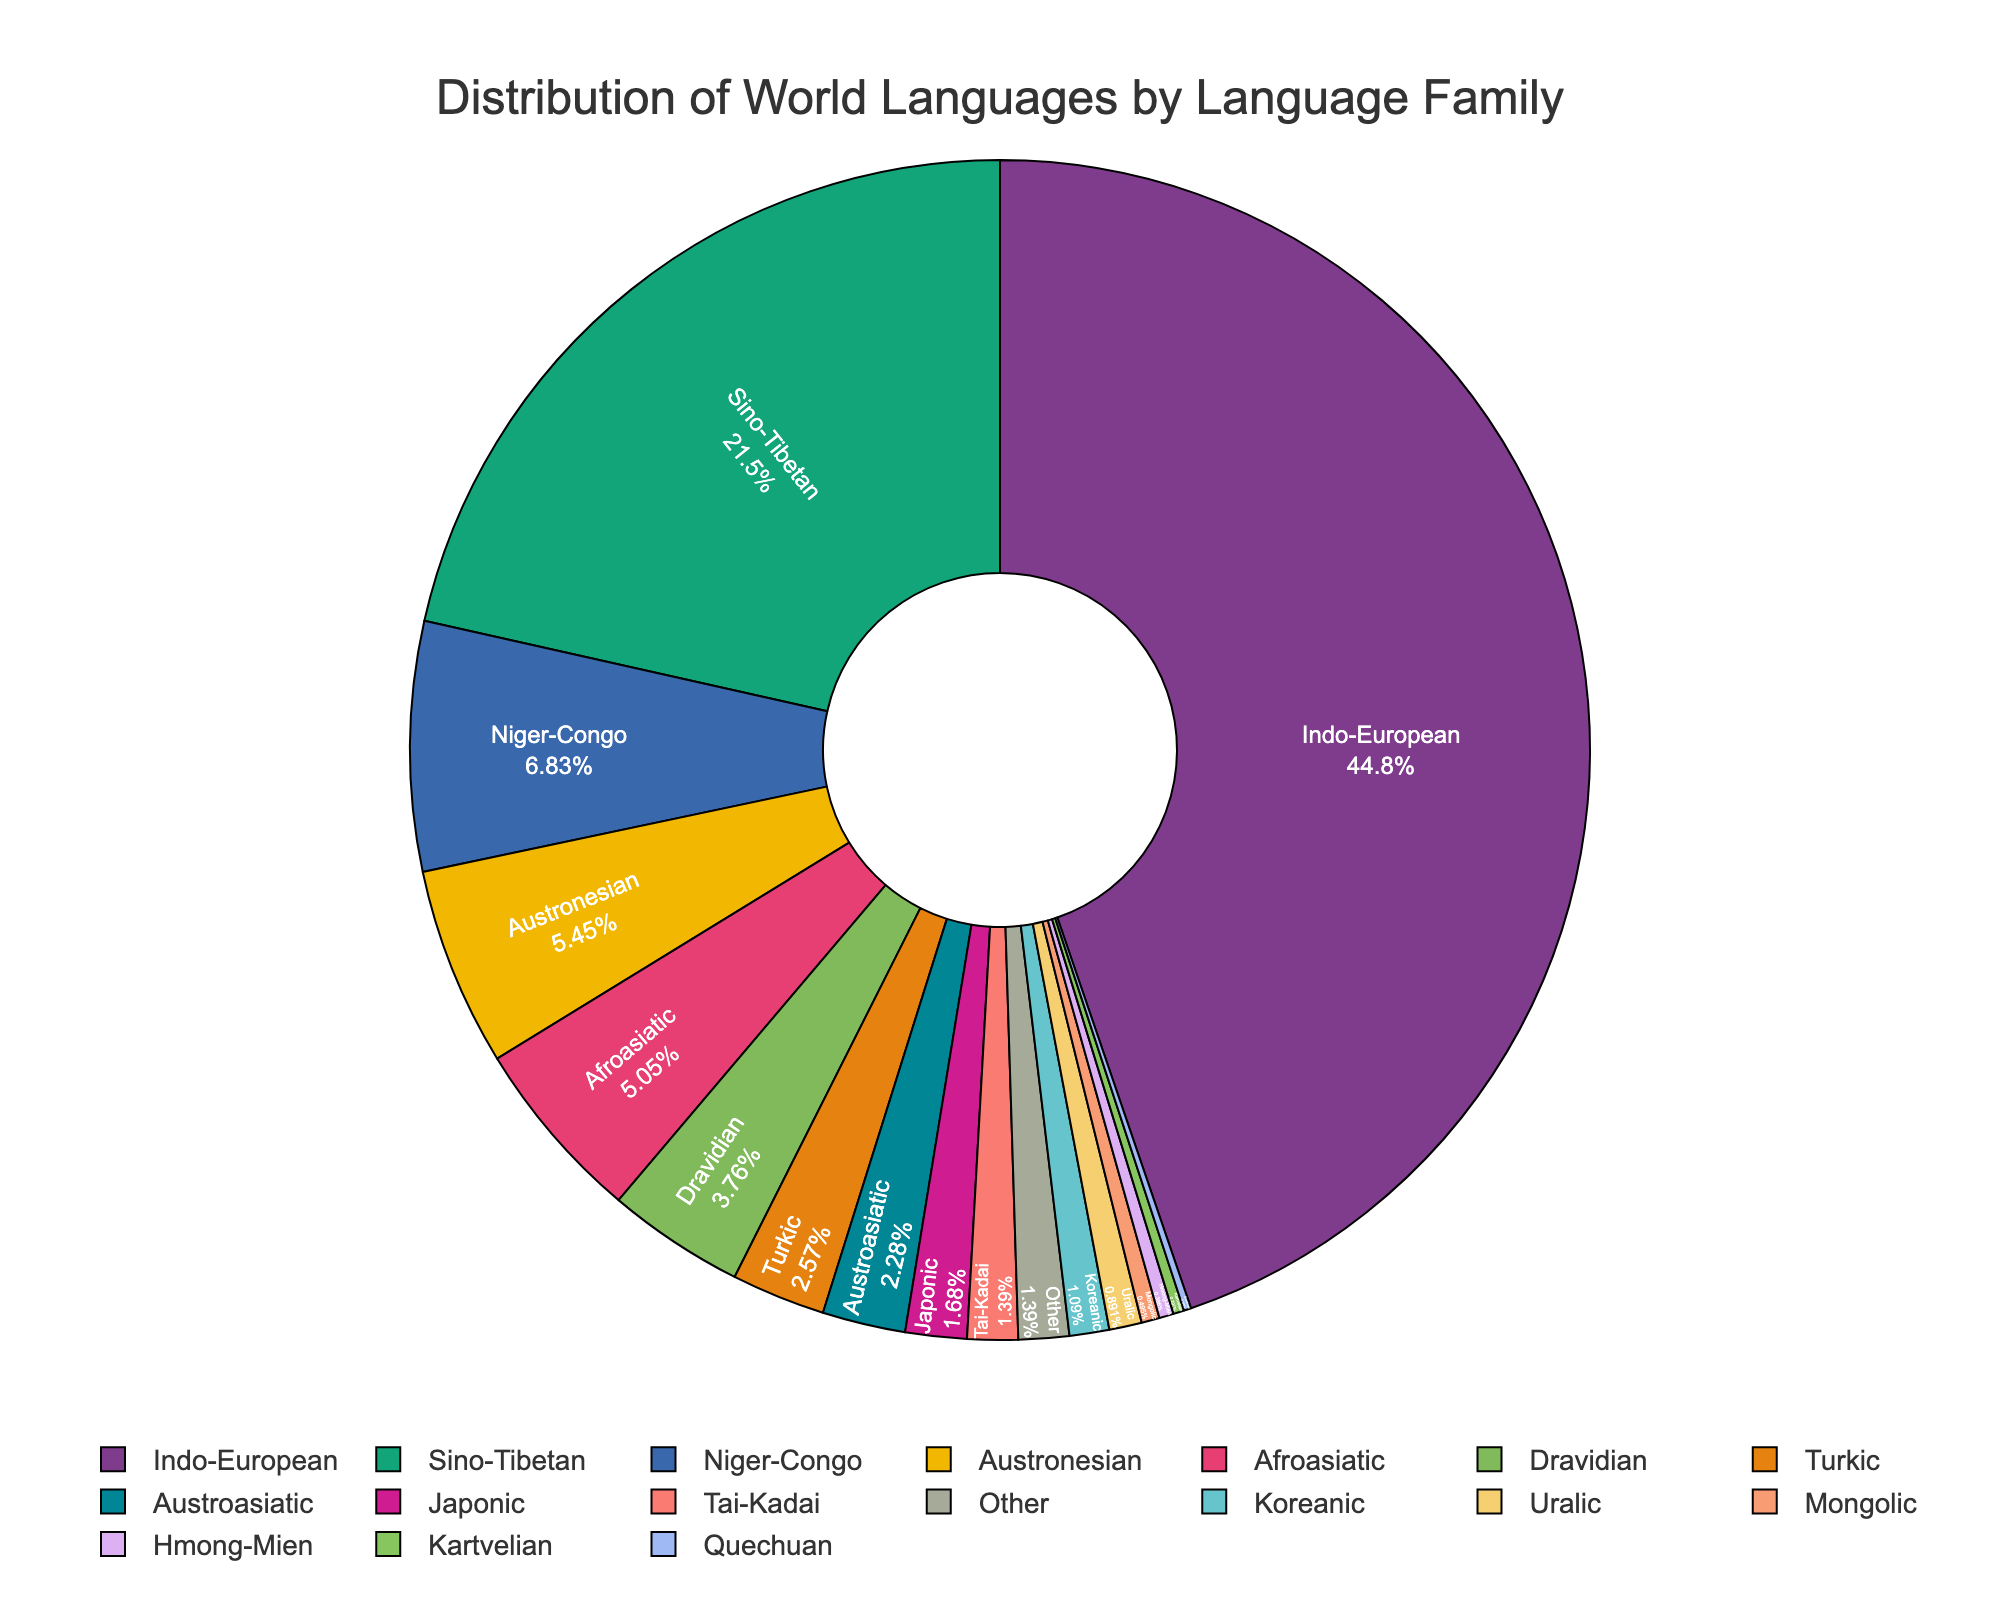What is the largest language family by percentage? The largest wedge in the pie chart represents the Indo-European family. By reading the label inside it, you see that it comprises 45.2% of the total.
Answer: Indo-European Which language families have a percentage greater than 20%? By examining the labels inside the wedges, you can see that Indo-European (45.2%) and Sino-Tibetan (21.7%) are the only families with percentages greater than 20%.
Answer: Indo-European, Sino-Tibetan How does the percentage of Afroasiatic compare to that of Austronesian? Check the pie chart for the labels 'Afroasiatic' and 'Austronesian'. Afroasiatic is 5.1%, while Austronesian is 5.5%. Thus, Austronesian is slightly larger.
Answer: Afroasiatic is smaller What is the total percentage of the top three largest language families? Add the percentages of Indo-European (45.2%), Sino-Tibetan (21.7%), and Niger-Congo (6.9%): 45.2 + 21.7 + 6.9 = 73.8%.
Answer: 73.8% How many language families on the chart comprise less than 2% each? Count the wedges with labels showing percentages less than 2%: Japonic (1.7%), Tai-Kadai (1.4%), Koreanic (1.1%), Uralic (0.9%), Mongolic (0.5%), Hmong-Mien (0.4%), Kartvelian (0.3%), Quechuan (0.2%), Other (1.4%). There are 9 segments.
Answer: 9 Which color represents the Sino-Tibetan language family? Look at the color of the wedge labeled 'Sino-Tibetan'. Identify its color visually; for instance, if it appears as purple in the chart, that would be the answer.
Answer: [Depend on the chart; describe specific color] Calculate the difference in percentage between Turkic and Dravidian language families. Check the pie chart for the labels 'Turkic' and 'Dravidian'. Turkic is 2.6% and Dravidian is 3.8%. Subtract 2.6 from 3.8 to get 1.2%.
Answer: 1.2% What is the combined percentage of language families with 3% or higher? Identify and add percentages for language families ≥ 3%: Indo-European (45.2%), Sino-Tibetan (21.7%), Niger-Congo (6.9%), Austronesian (5.5%), Afroasiatic (5.1%), Dravidian (3.8%) totaling 88.2%.
Answer: 88.2% What percentage is shared by the 'Other' category and two smallest families? The 'Other' category is 1.4%, and the two smallest families are Quechuan (0.2%) and Kartvelian (0.3%). Add these: 1.4 + 0.2 + 0.3 = 1.9%.
Answer: 1.9% 